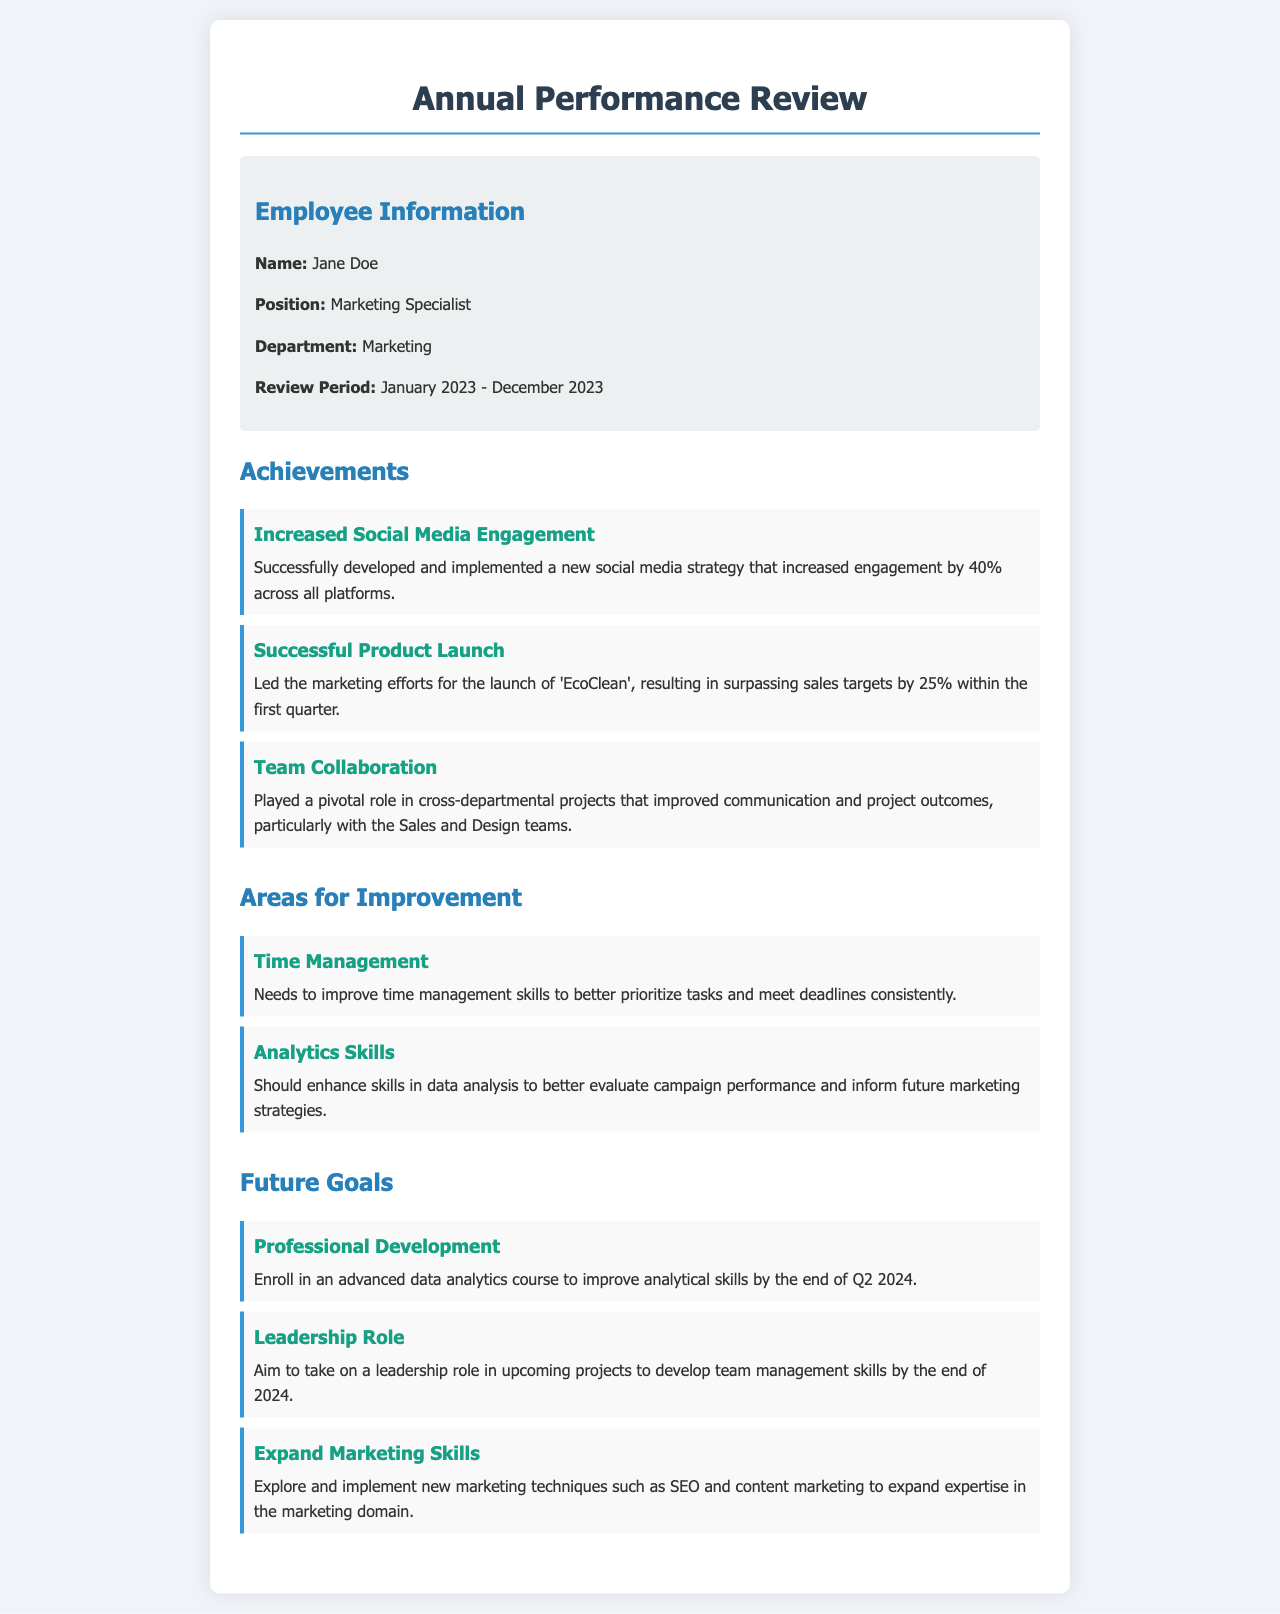What is the employee's name? The employee's name is mentioned in the employee information section of the document.
Answer: Jane Doe What is the position of Jane Doe? The position of Jane Doe is specified in the employee information section.
Answer: Marketing Specialist What percentage did social media engagement increase by? The percentage increase in social media engagement is detailed in the achievements section of the document.
Answer: 40% What was the sales target surpass for the product 'EcoClean'? The specific amount by which sales targets were surpassed is included in the achievements section.
Answer: 25% Which skill does Jane need to improve for better prioritization? The skill that Jane needs to improve is mentioned in the areas for improvement section.
Answer: Time Management What course does Jane aim to enroll in for professional development? The type of course Jane wants to enroll in for professional development is described in the future goals section.
Answer: Advanced data analytics course What year does Jane aim to take on a leadership role? The timeframe for Jane’s goal of taking on a leadership role is specified in the future goals section.
Answer: End of 2024 Which departments did Jane collaborate with for better communication? The departments Jane collaborated with to improve outcomes are stated in the achievements section.
Answer: Sales and Design teams What is one area Jane should enhance related to campaign performance? The area that needs enhancement related to campaign performance is identified in the areas for improvement section.
Answer: Analytics Skills 